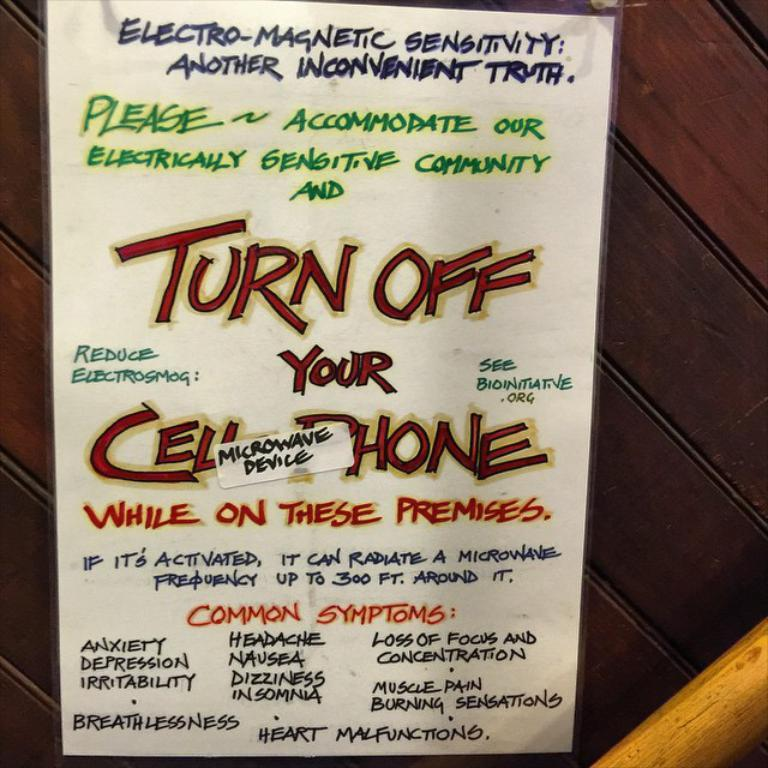Provide a one-sentence caption for the provided image. A sign asks visitors to turn their cellphones off while on the premises and lists reasons why. 